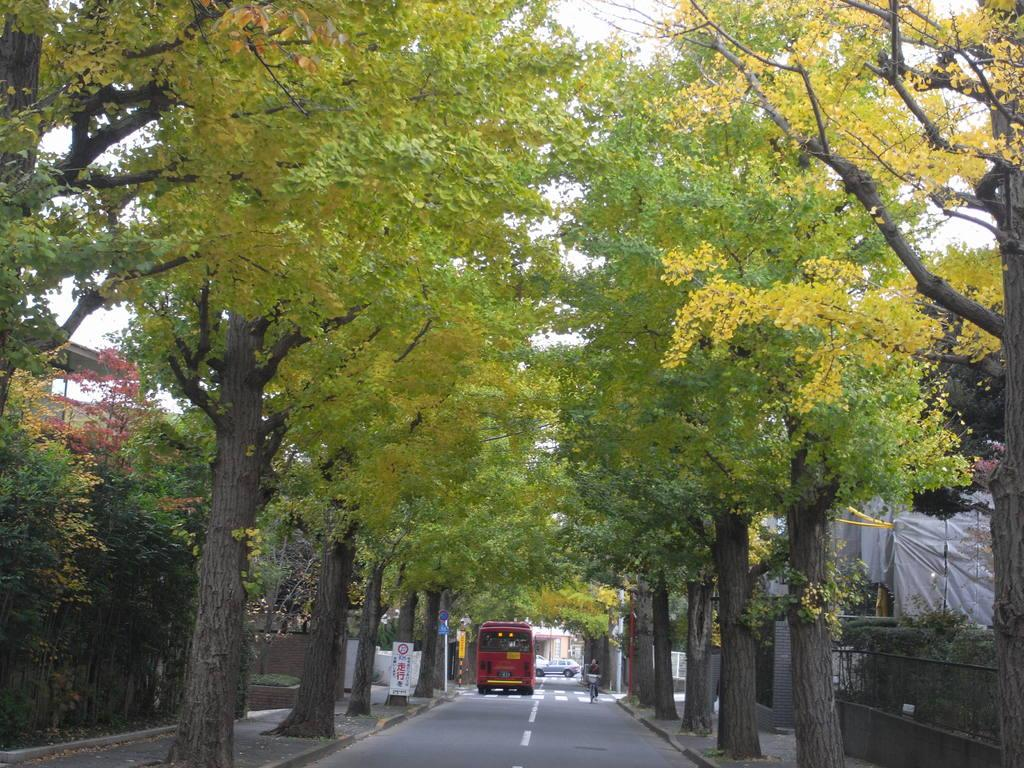What type of natural elements can be seen in the image? There are trees in the image. What is located at the bottom of the image? There is a road at the bottom of the image. What is moving along the road in the image? Vehicles are visible on the road. What is visible in the background of the image? There is sky visible in the background of the image. What structures can be seen on the right side of the image? There is a wall and a shed on the right side of the image. What type of shirt is the actor wearing in the image? There is no actor or shirt present in the image. 